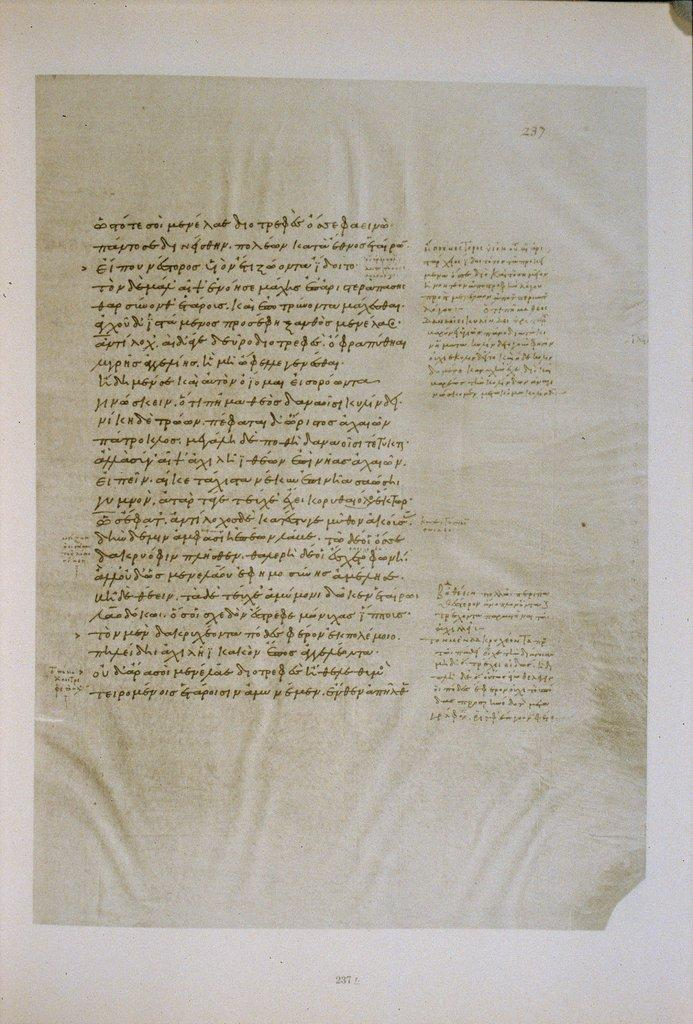Provide a one-sentence caption for the provided image. A single page is laid out on a white surface and numbered page 237. 